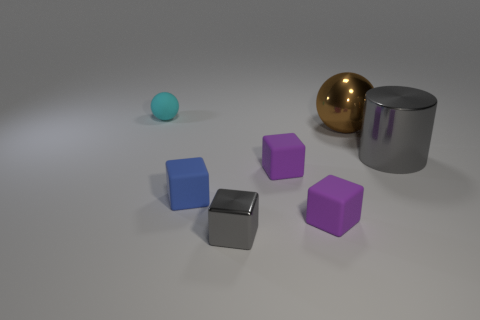Are there more tiny rubber spheres behind the metal sphere than blue cubes?
Offer a very short reply. No. What number of things are either gray objects that are right of the tiny shiny block or cyan matte spheres?
Provide a succinct answer. 2. What number of small purple blocks are made of the same material as the brown object?
Provide a succinct answer. 0. What shape is the metal object that is the same color as the big cylinder?
Provide a short and direct response. Cube. Is there another thing that has the same shape as the small cyan matte object?
Provide a short and direct response. Yes. There is a metallic thing that is the same size as the brown sphere; what is its shape?
Offer a very short reply. Cylinder. Is the color of the metallic cylinder the same as the metallic object left of the large brown metallic object?
Keep it short and to the point. Yes. What number of objects are behind the shiny object that is on the right side of the large brown shiny thing?
Keep it short and to the point. 2. There is a object that is both behind the big gray cylinder and right of the blue matte cube; what is its size?
Your response must be concise. Large. Is there a brown cylinder of the same size as the gray cube?
Give a very brief answer. No. 